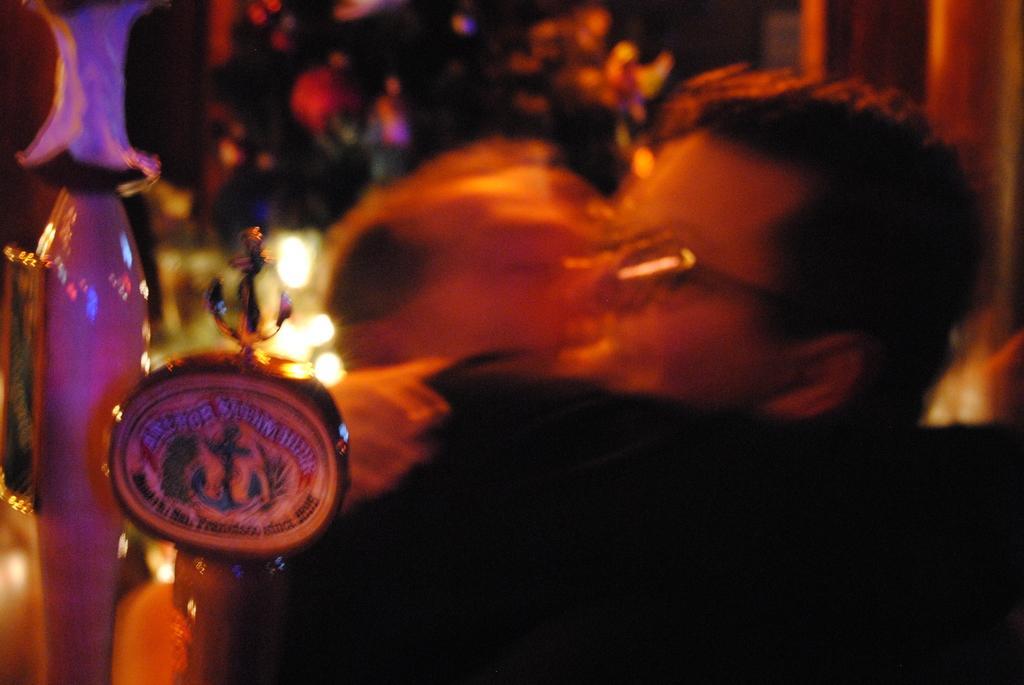In one or two sentences, can you explain what this image depicts? In this image I can see few thing in the front and on one thing I can see something is written. On the right side of this image I can see few people and I can see this image is little bit blurry. 